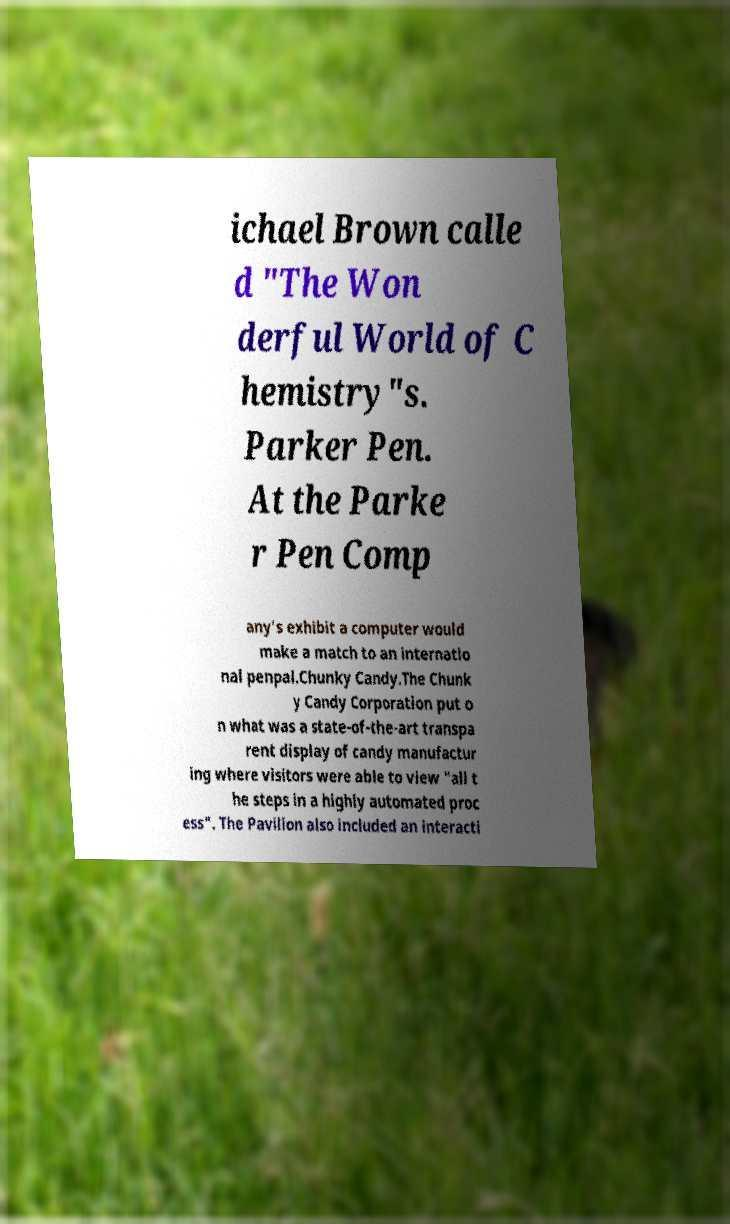Can you read and provide the text displayed in the image?This photo seems to have some interesting text. Can you extract and type it out for me? ichael Brown calle d "The Won derful World of C hemistry"s. Parker Pen. At the Parke r Pen Comp any's exhibit a computer would make a match to an internatio nal penpal.Chunky Candy.The Chunk y Candy Corporation put o n what was a state-of-the-art transpa rent display of candy manufactur ing where visitors were able to view "all t he steps in a highly automated proc ess". The Pavilion also included an interacti 